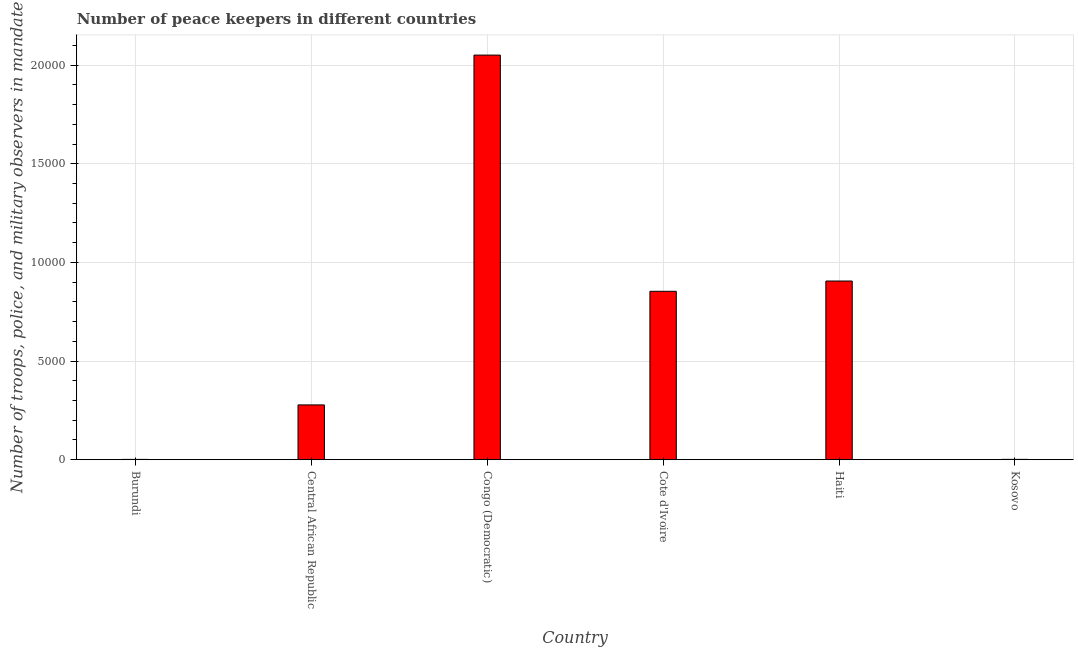Does the graph contain any zero values?
Ensure brevity in your answer.  No. What is the title of the graph?
Your answer should be very brief. Number of peace keepers in different countries. What is the label or title of the Y-axis?
Offer a very short reply. Number of troops, police, and military observers in mandate. What is the number of peace keepers in Haiti?
Ensure brevity in your answer.  9057. Across all countries, what is the maximum number of peace keepers?
Offer a very short reply. 2.05e+04. Across all countries, what is the minimum number of peace keepers?
Provide a short and direct response. 15. In which country was the number of peace keepers maximum?
Give a very brief answer. Congo (Democratic). In which country was the number of peace keepers minimum?
Make the answer very short. Burundi. What is the sum of the number of peace keepers?
Your response must be concise. 4.09e+04. What is the difference between the number of peace keepers in Cote d'Ivoire and Haiti?
Your answer should be very brief. -521. What is the average number of peace keepers per country?
Keep it short and to the point. 6818. What is the median number of peace keepers?
Give a very brief answer. 5656.5. In how many countries, is the number of peace keepers greater than 13000 ?
Provide a short and direct response. 1. What is the ratio of the number of peace keepers in Cote d'Ivoire to that in Kosovo?
Ensure brevity in your answer.  502.12. Is the number of peace keepers in Burundi less than that in Congo (Democratic)?
Keep it short and to the point. Yes. What is the difference between the highest and the second highest number of peace keepers?
Your response must be concise. 1.15e+04. Is the sum of the number of peace keepers in Central African Republic and Haiti greater than the maximum number of peace keepers across all countries?
Keep it short and to the point. No. What is the difference between the highest and the lowest number of peace keepers?
Your answer should be compact. 2.05e+04. How many bars are there?
Provide a short and direct response. 6. Are all the bars in the graph horizontal?
Your answer should be very brief. No. What is the Number of troops, police, and military observers in mandate of Burundi?
Your response must be concise. 15. What is the Number of troops, police, and military observers in mandate of Central African Republic?
Keep it short and to the point. 2777. What is the Number of troops, police, and military observers in mandate in Congo (Democratic)?
Offer a very short reply. 2.05e+04. What is the Number of troops, police, and military observers in mandate of Cote d'Ivoire?
Your answer should be compact. 8536. What is the Number of troops, police, and military observers in mandate of Haiti?
Offer a very short reply. 9057. What is the Number of troops, police, and military observers in mandate of Kosovo?
Your response must be concise. 17. What is the difference between the Number of troops, police, and military observers in mandate in Burundi and Central African Republic?
Provide a succinct answer. -2762. What is the difference between the Number of troops, police, and military observers in mandate in Burundi and Congo (Democratic)?
Offer a very short reply. -2.05e+04. What is the difference between the Number of troops, police, and military observers in mandate in Burundi and Cote d'Ivoire?
Offer a very short reply. -8521. What is the difference between the Number of troops, police, and military observers in mandate in Burundi and Haiti?
Provide a short and direct response. -9042. What is the difference between the Number of troops, police, and military observers in mandate in Central African Republic and Congo (Democratic)?
Make the answer very short. -1.77e+04. What is the difference between the Number of troops, police, and military observers in mandate in Central African Republic and Cote d'Ivoire?
Offer a terse response. -5759. What is the difference between the Number of troops, police, and military observers in mandate in Central African Republic and Haiti?
Your answer should be very brief. -6280. What is the difference between the Number of troops, police, and military observers in mandate in Central African Republic and Kosovo?
Offer a terse response. 2760. What is the difference between the Number of troops, police, and military observers in mandate in Congo (Democratic) and Cote d'Ivoire?
Your answer should be very brief. 1.20e+04. What is the difference between the Number of troops, police, and military observers in mandate in Congo (Democratic) and Haiti?
Ensure brevity in your answer.  1.15e+04. What is the difference between the Number of troops, police, and military observers in mandate in Congo (Democratic) and Kosovo?
Provide a short and direct response. 2.05e+04. What is the difference between the Number of troops, police, and military observers in mandate in Cote d'Ivoire and Haiti?
Provide a succinct answer. -521. What is the difference between the Number of troops, police, and military observers in mandate in Cote d'Ivoire and Kosovo?
Your answer should be compact. 8519. What is the difference between the Number of troops, police, and military observers in mandate in Haiti and Kosovo?
Give a very brief answer. 9040. What is the ratio of the Number of troops, police, and military observers in mandate in Burundi to that in Central African Republic?
Your answer should be very brief. 0.01. What is the ratio of the Number of troops, police, and military observers in mandate in Burundi to that in Congo (Democratic)?
Offer a terse response. 0. What is the ratio of the Number of troops, police, and military observers in mandate in Burundi to that in Cote d'Ivoire?
Provide a succinct answer. 0. What is the ratio of the Number of troops, police, and military observers in mandate in Burundi to that in Haiti?
Make the answer very short. 0. What is the ratio of the Number of troops, police, and military observers in mandate in Burundi to that in Kosovo?
Keep it short and to the point. 0.88. What is the ratio of the Number of troops, police, and military observers in mandate in Central African Republic to that in Congo (Democratic)?
Your response must be concise. 0.14. What is the ratio of the Number of troops, police, and military observers in mandate in Central African Republic to that in Cote d'Ivoire?
Make the answer very short. 0.33. What is the ratio of the Number of troops, police, and military observers in mandate in Central African Republic to that in Haiti?
Provide a short and direct response. 0.31. What is the ratio of the Number of troops, police, and military observers in mandate in Central African Republic to that in Kosovo?
Make the answer very short. 163.35. What is the ratio of the Number of troops, police, and military observers in mandate in Congo (Democratic) to that in Cote d'Ivoire?
Give a very brief answer. 2.4. What is the ratio of the Number of troops, police, and military observers in mandate in Congo (Democratic) to that in Haiti?
Make the answer very short. 2.26. What is the ratio of the Number of troops, police, and military observers in mandate in Congo (Democratic) to that in Kosovo?
Your answer should be very brief. 1206.41. What is the ratio of the Number of troops, police, and military observers in mandate in Cote d'Ivoire to that in Haiti?
Provide a short and direct response. 0.94. What is the ratio of the Number of troops, police, and military observers in mandate in Cote d'Ivoire to that in Kosovo?
Ensure brevity in your answer.  502.12. What is the ratio of the Number of troops, police, and military observers in mandate in Haiti to that in Kosovo?
Give a very brief answer. 532.76. 